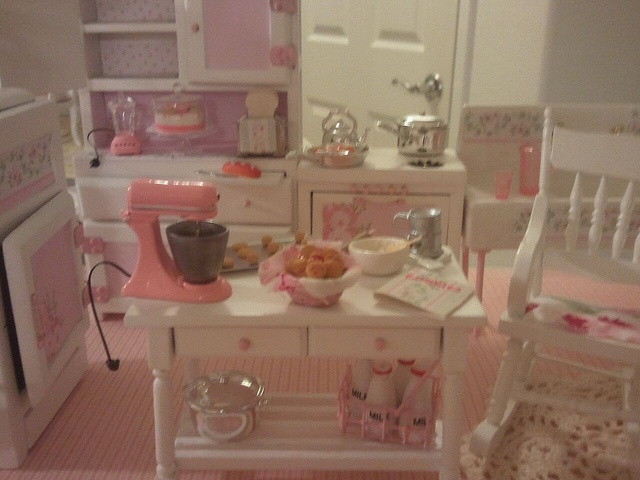Describe the objects in this image and their specific colors. I can see chair in gray and tan tones, oven in gray and tan tones, refrigerator in gray and brown tones, bowl in gray, maroon, brown, and black tones, and bottle in gray, brown, and maroon tones in this image. 